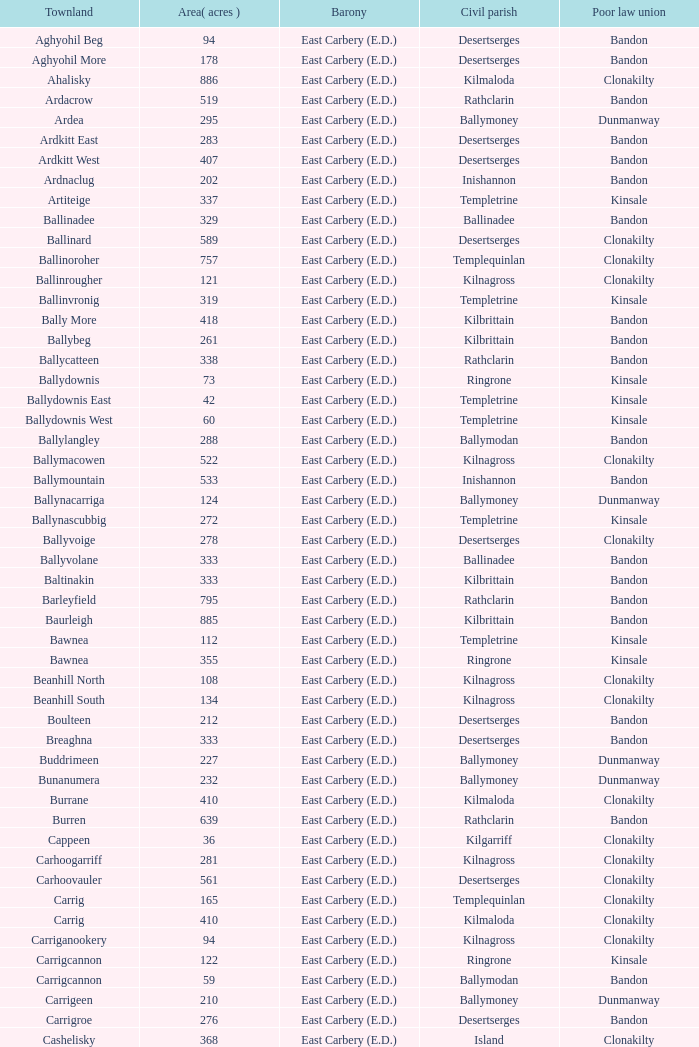What is the greatest extent (in acres) of the knockacullen townland? 381.0. 